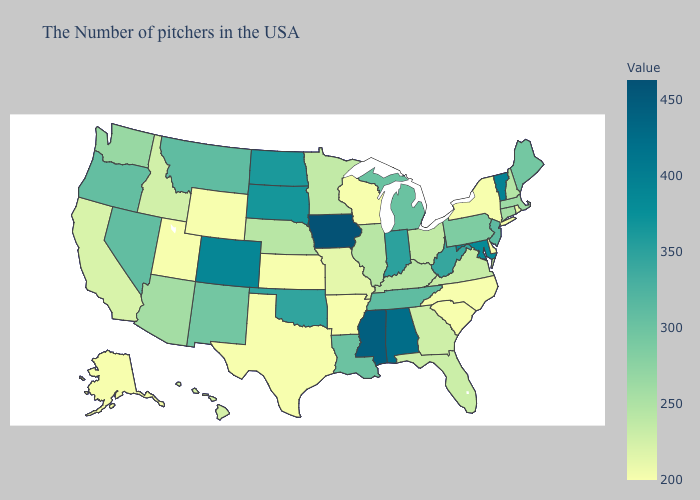Does Utah have the lowest value in the West?
Short answer required. Yes. Among the states that border Rhode Island , which have the highest value?
Concise answer only. Massachusetts. Does Vermont have a lower value than Mississippi?
Be succinct. Yes. Is the legend a continuous bar?
Answer briefly. Yes. Does Maine have the lowest value in the Northeast?
Answer briefly. No. Among the states that border New Jersey , which have the highest value?
Give a very brief answer. Pennsylvania. Which states have the lowest value in the South?
Answer briefly. Delaware, North Carolina, South Carolina, Arkansas, Texas. Is the legend a continuous bar?
Answer briefly. Yes. Is the legend a continuous bar?
Write a very short answer. Yes. 